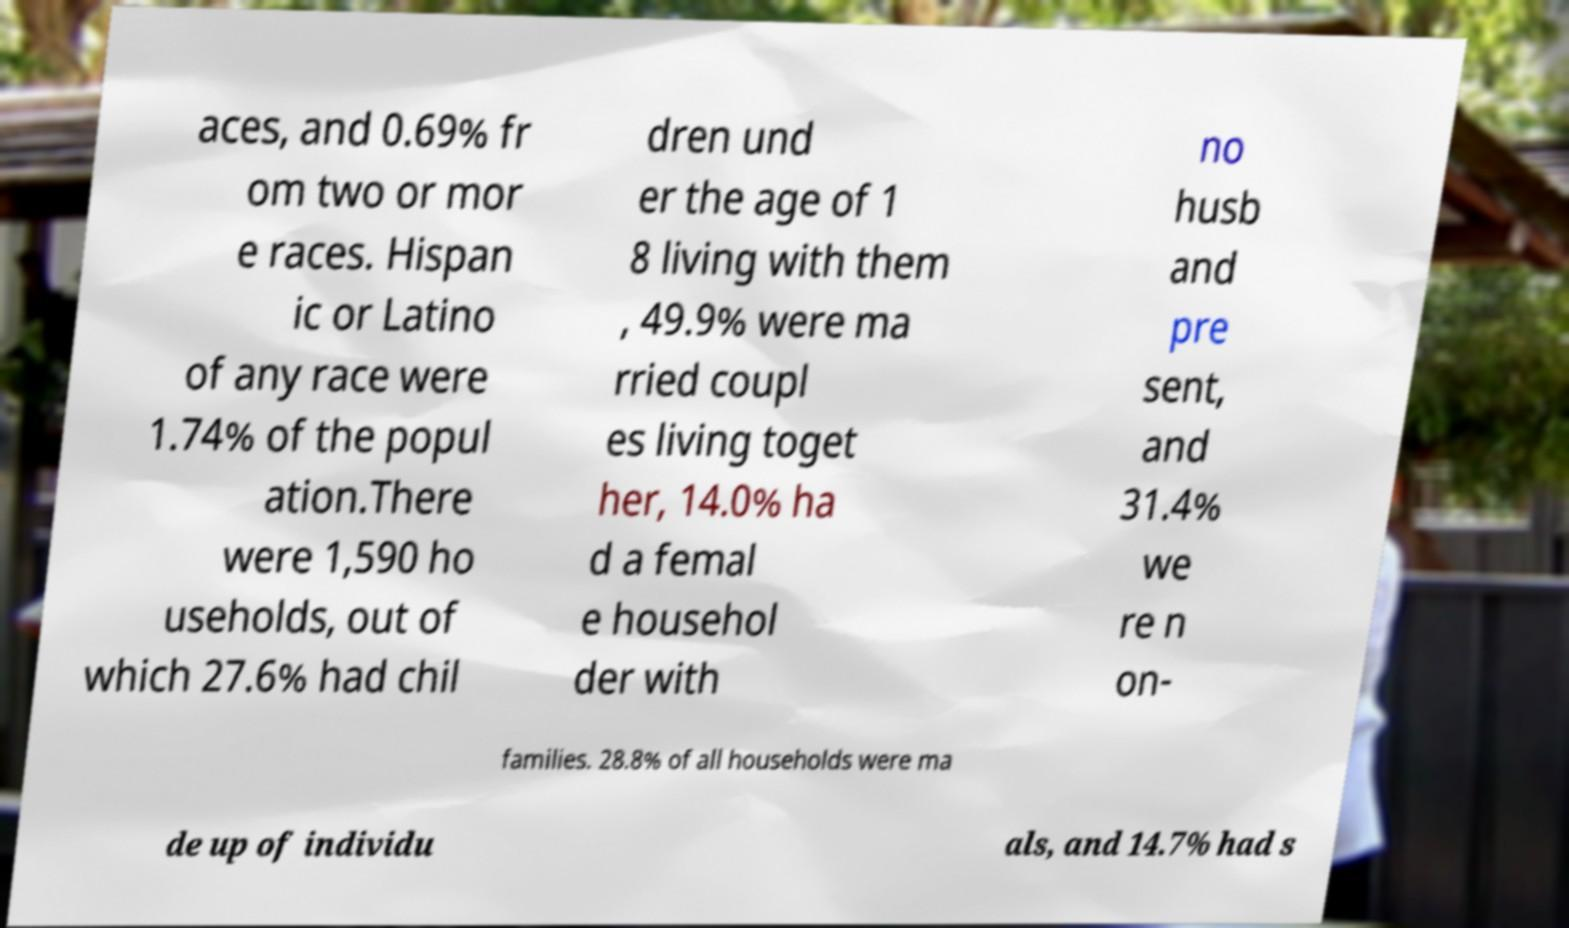I need the written content from this picture converted into text. Can you do that? aces, and 0.69% fr om two or mor e races. Hispan ic or Latino of any race were 1.74% of the popul ation.There were 1,590 ho useholds, out of which 27.6% had chil dren und er the age of 1 8 living with them , 49.9% were ma rried coupl es living toget her, 14.0% ha d a femal e househol der with no husb and pre sent, and 31.4% we re n on- families. 28.8% of all households were ma de up of individu als, and 14.7% had s 